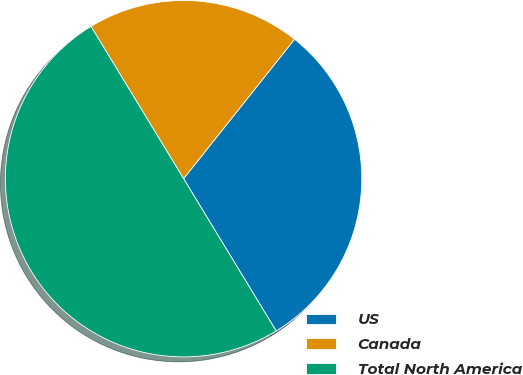Convert chart to OTSL. <chart><loc_0><loc_0><loc_500><loc_500><pie_chart><fcel>US<fcel>Canada<fcel>Total North America<nl><fcel>30.61%<fcel>19.39%<fcel>50.0%<nl></chart> 